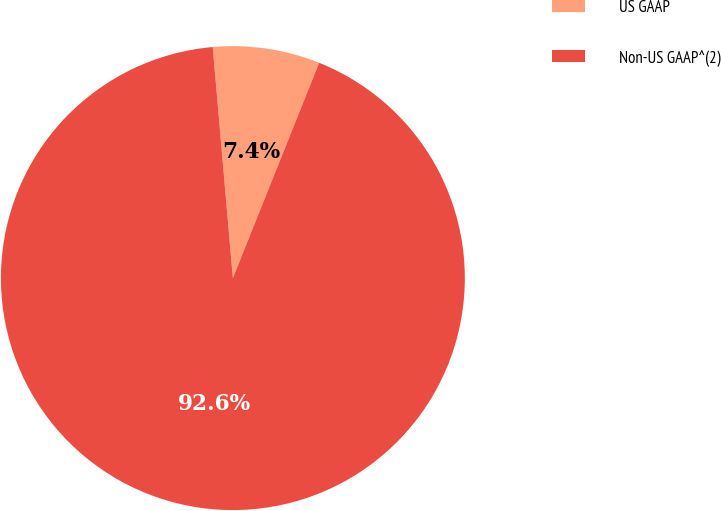<chart> <loc_0><loc_0><loc_500><loc_500><pie_chart><fcel>US GAAP<fcel>Non-US GAAP^(2)<nl><fcel>7.45%<fcel>92.55%<nl></chart> 